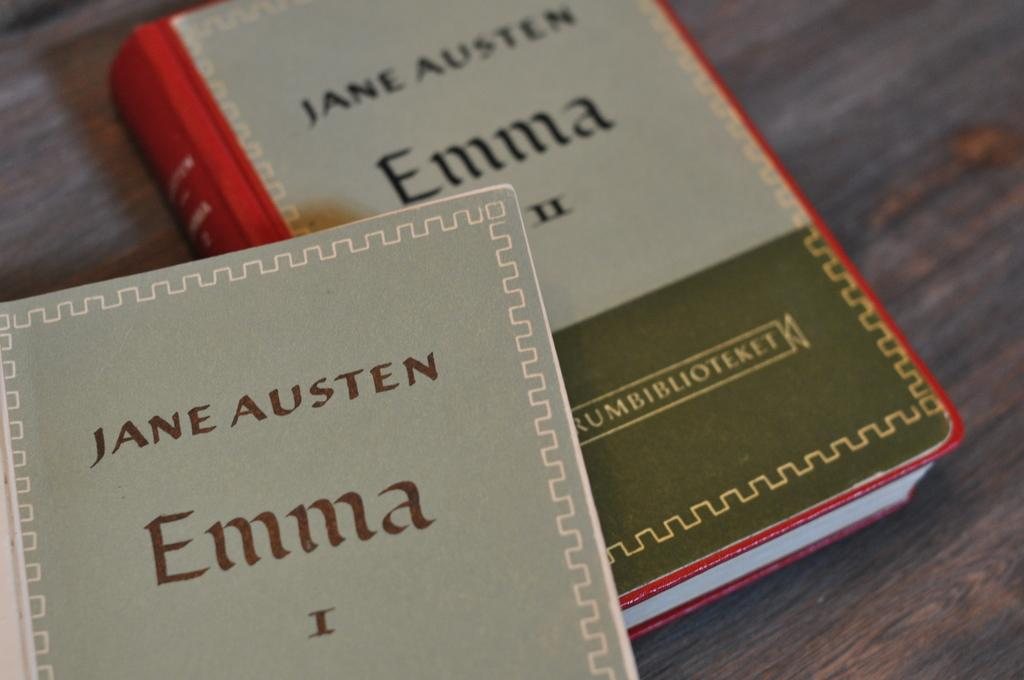<image>
Share a concise interpretation of the image provided. Two books of Jane Austen's Emma on wood shelf 